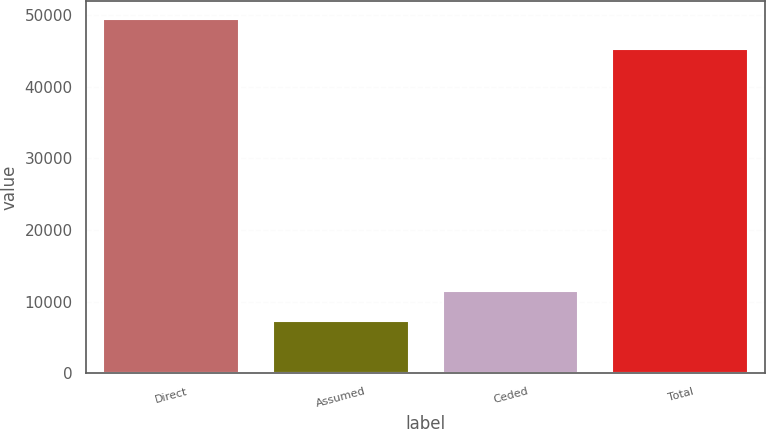Convert chart to OTSL. <chart><loc_0><loc_0><loc_500><loc_500><bar_chart><fcel>Direct<fcel>Assumed<fcel>Ceded<fcel>Total<nl><fcel>49452.3<fcel>7239<fcel>11457.3<fcel>45234<nl></chart> 